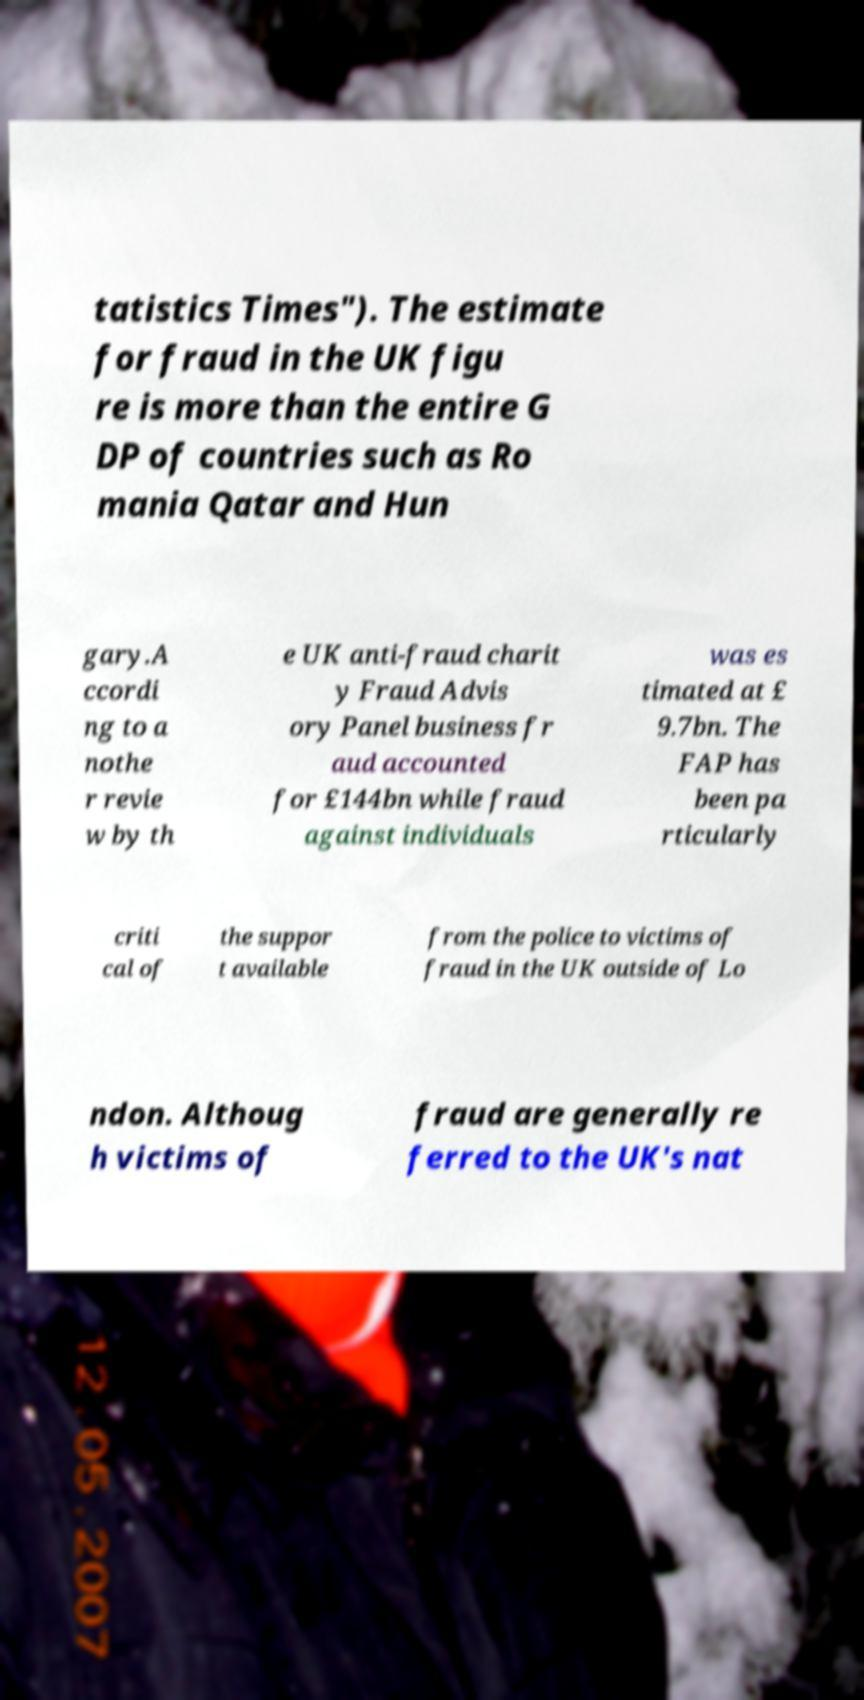Can you accurately transcribe the text from the provided image for me? tatistics Times"). The estimate for fraud in the UK figu re is more than the entire G DP of countries such as Ro mania Qatar and Hun gary.A ccordi ng to a nothe r revie w by th e UK anti-fraud charit y Fraud Advis ory Panel business fr aud accounted for £144bn while fraud against individuals was es timated at £ 9.7bn. The FAP has been pa rticularly criti cal of the suppor t available from the police to victims of fraud in the UK outside of Lo ndon. Althoug h victims of fraud are generally re ferred to the UK's nat 